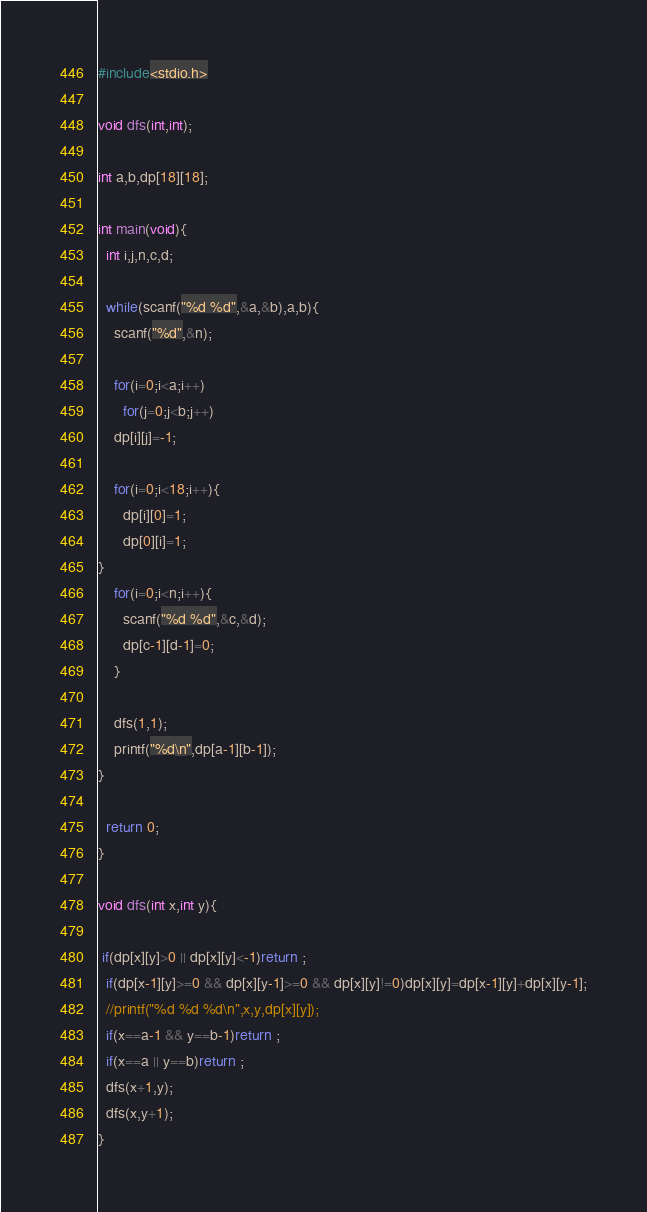<code> <loc_0><loc_0><loc_500><loc_500><_C_>#include<stdio.h>

void dfs(int,int);

int a,b,dp[18][18];

int main(void){
  int i,j,n,c,d;

  while(scanf("%d %d",&a,&b),a,b){
    scanf("%d",&n);

    for(i=0;i<a;i++)
      for(j=0;j<b;j++)
	dp[i][j]=-1;

    for(i=0;i<18;i++){
      dp[i][0]=1;
      dp[0][i]=1;
}
    for(i=0;i<n;i++){
      scanf("%d %d",&c,&d);
      dp[c-1][d-1]=0;
    }

    dfs(1,1);
    printf("%d\n",dp[a-1][b-1]);
}

  return 0;
}

void dfs(int x,int y){

 if(dp[x][y]>0 || dp[x][y]<-1)return ;
  if(dp[x-1][y]>=0 && dp[x][y-1]>=0 && dp[x][y]!=0)dp[x][y]=dp[x-1][y]+dp[x][y-1];
  //printf("%d %d %d\n",x,y,dp[x][y]);
  if(x==a-1 && y==b-1)return ;
  if(x==a || y==b)return ;
  dfs(x+1,y);
  dfs(x,y+1);
}</code> 